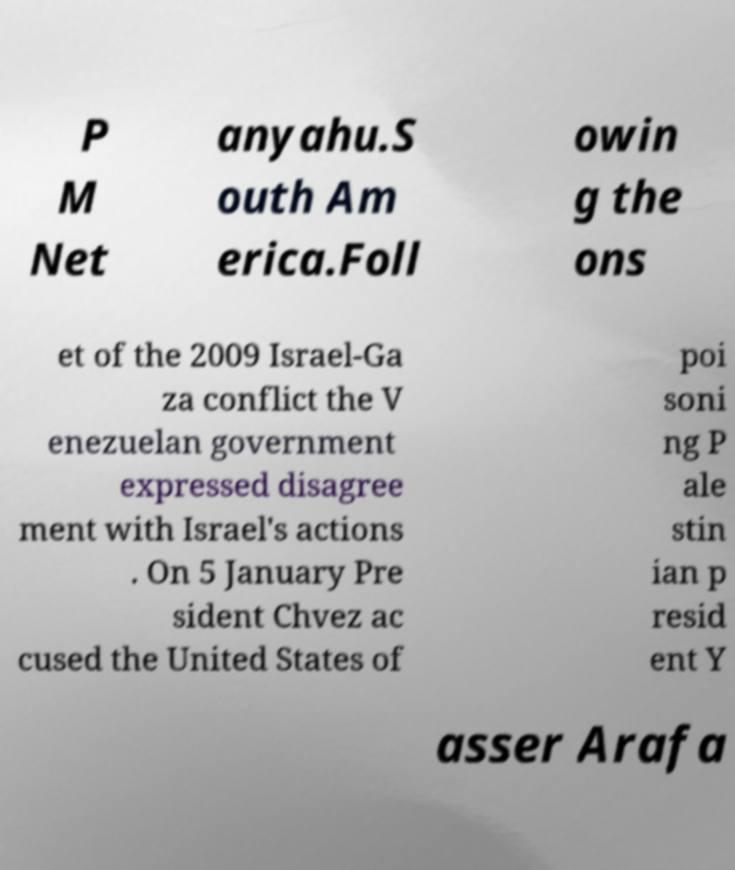Please read and relay the text visible in this image. What does it say? P M Net anyahu.S outh Am erica.Foll owin g the ons et of the 2009 Israel-Ga za conflict the V enezuelan government expressed disagree ment with Israel's actions . On 5 January Pre sident Chvez ac cused the United States of poi soni ng P ale stin ian p resid ent Y asser Arafa 